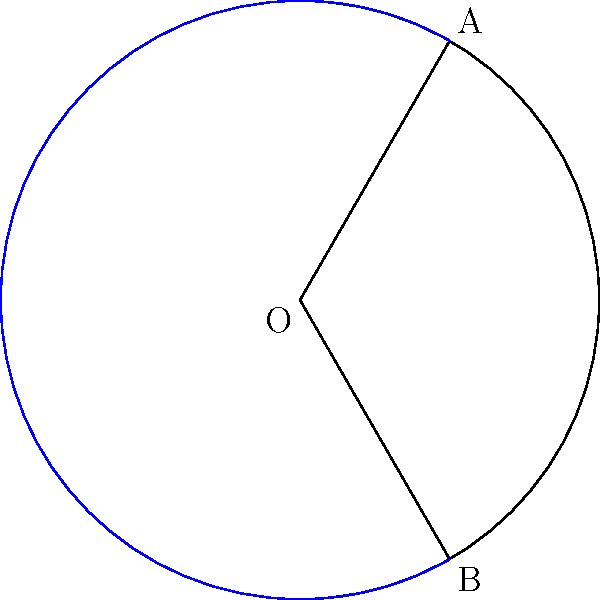As you rest at a wayside inn, you find yourself pondering the geometry of circular segments. Consider a circle with radius $r$ and a central angle $\theta$ (in radians). How would you express the area of the circular segment formed by this angle in terms of $r$ and $\theta$? Let's approach this step-by-step:

1) The area of a circular segment is the difference between the area of a sector and the area of a triangle formed by the two radii.

2) Area of the sector:
   $$A_{sector} = \frac{1}{2}r^2\theta$$

3) Area of the triangle:
   $$A_{triangle} = \frac{1}{2}r^2\sin\theta$$

4) Therefore, the area of the segment is:
   $$A_{segment} = A_{sector} - A_{triangle}$$

5) Substituting the expressions:
   $$A_{segment} = \frac{1}{2}r^2\theta - \frac{1}{2}r^2\sin\theta$$

6) Factoring out $\frac{1}{2}r^2$:
   $$A_{segment} = \frac{1}{2}r^2(\theta - \sin\theta)$$

This formula gives the area of the circular segment in terms of $r$ and $\theta$.
Answer: $$A_{segment} = \frac{1}{2}r^2(\theta - \sin\theta)$$ 